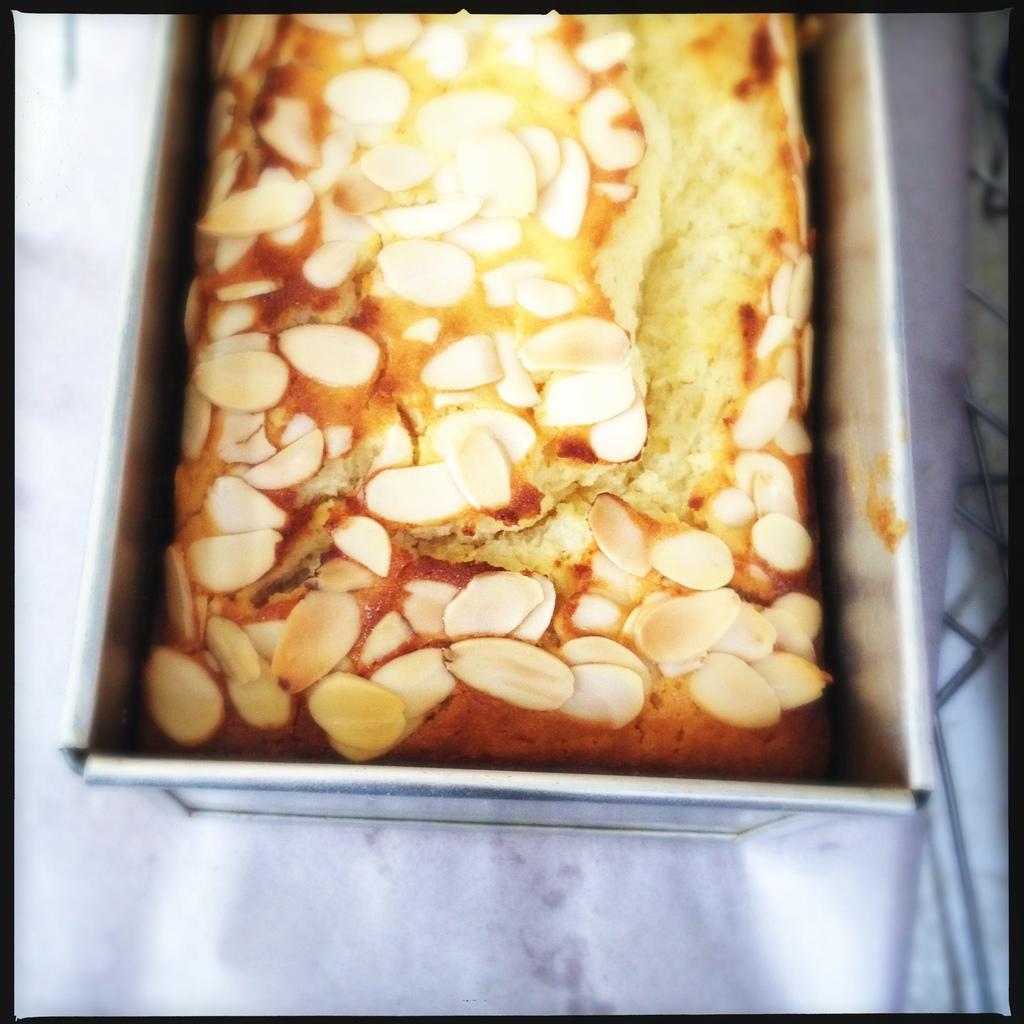Please provide a concise description of this image. In this image I can see the food in the box. The food is in cream and brown color. The box is in silver color. It is on the white surface. 